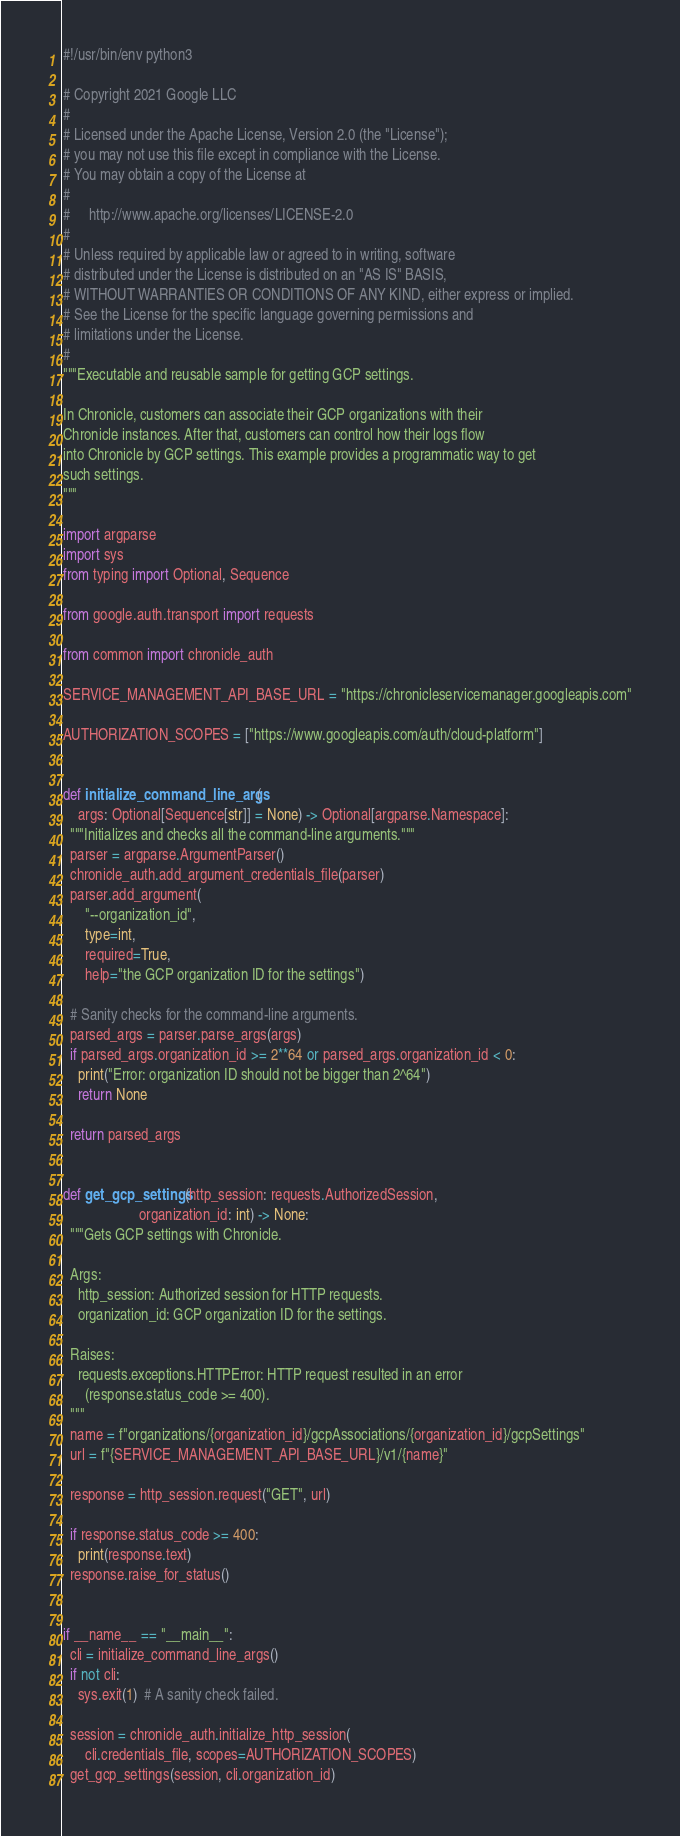Convert code to text. <code><loc_0><loc_0><loc_500><loc_500><_Python_>#!/usr/bin/env python3

# Copyright 2021 Google LLC
#
# Licensed under the Apache License, Version 2.0 (the "License");
# you may not use this file except in compliance with the License.
# You may obtain a copy of the License at
#
#     http://www.apache.org/licenses/LICENSE-2.0
#
# Unless required by applicable law or agreed to in writing, software
# distributed under the License is distributed on an "AS IS" BASIS,
# WITHOUT WARRANTIES OR CONDITIONS OF ANY KIND, either express or implied.
# See the License for the specific language governing permissions and
# limitations under the License.
#
"""Executable and reusable sample for getting GCP settings.

In Chronicle, customers can associate their GCP organizations with their
Chronicle instances. After that, customers can control how their logs flow
into Chronicle by GCP settings. This example provides a programmatic way to get
such settings.
"""

import argparse
import sys
from typing import Optional, Sequence

from google.auth.transport import requests

from common import chronicle_auth

SERVICE_MANAGEMENT_API_BASE_URL = "https://chronicleservicemanager.googleapis.com"

AUTHORIZATION_SCOPES = ["https://www.googleapis.com/auth/cloud-platform"]


def initialize_command_line_args(
    args: Optional[Sequence[str]] = None) -> Optional[argparse.Namespace]:
  """Initializes and checks all the command-line arguments."""
  parser = argparse.ArgumentParser()
  chronicle_auth.add_argument_credentials_file(parser)
  parser.add_argument(
      "--organization_id",
      type=int,
      required=True,
      help="the GCP organization ID for the settings")

  # Sanity checks for the command-line arguments.
  parsed_args = parser.parse_args(args)
  if parsed_args.organization_id >= 2**64 or parsed_args.organization_id < 0:
    print("Error: organization ID should not be bigger than 2^64")
    return None

  return parsed_args


def get_gcp_settings(http_session: requests.AuthorizedSession,
                     organization_id: int) -> None:
  """Gets GCP settings with Chronicle.

  Args:
    http_session: Authorized session for HTTP requests.
    organization_id: GCP organization ID for the settings.

  Raises:
    requests.exceptions.HTTPError: HTTP request resulted in an error
      (response.status_code >= 400).
  """
  name = f"organizations/{organization_id}/gcpAssociations/{organization_id}/gcpSettings"
  url = f"{SERVICE_MANAGEMENT_API_BASE_URL}/v1/{name}"

  response = http_session.request("GET", url)

  if response.status_code >= 400:
    print(response.text)
  response.raise_for_status()


if __name__ == "__main__":
  cli = initialize_command_line_args()
  if not cli:
    sys.exit(1)  # A sanity check failed.

  session = chronicle_auth.initialize_http_session(
      cli.credentials_file, scopes=AUTHORIZATION_SCOPES)
  get_gcp_settings(session, cli.organization_id)
</code> 